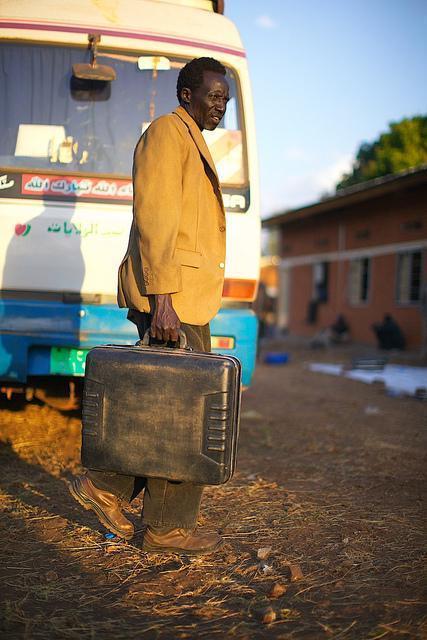How many train cars are under the poles?
Give a very brief answer. 0. 